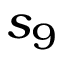<formula> <loc_0><loc_0><loc_500><loc_500>s _ { 9 }</formula> 